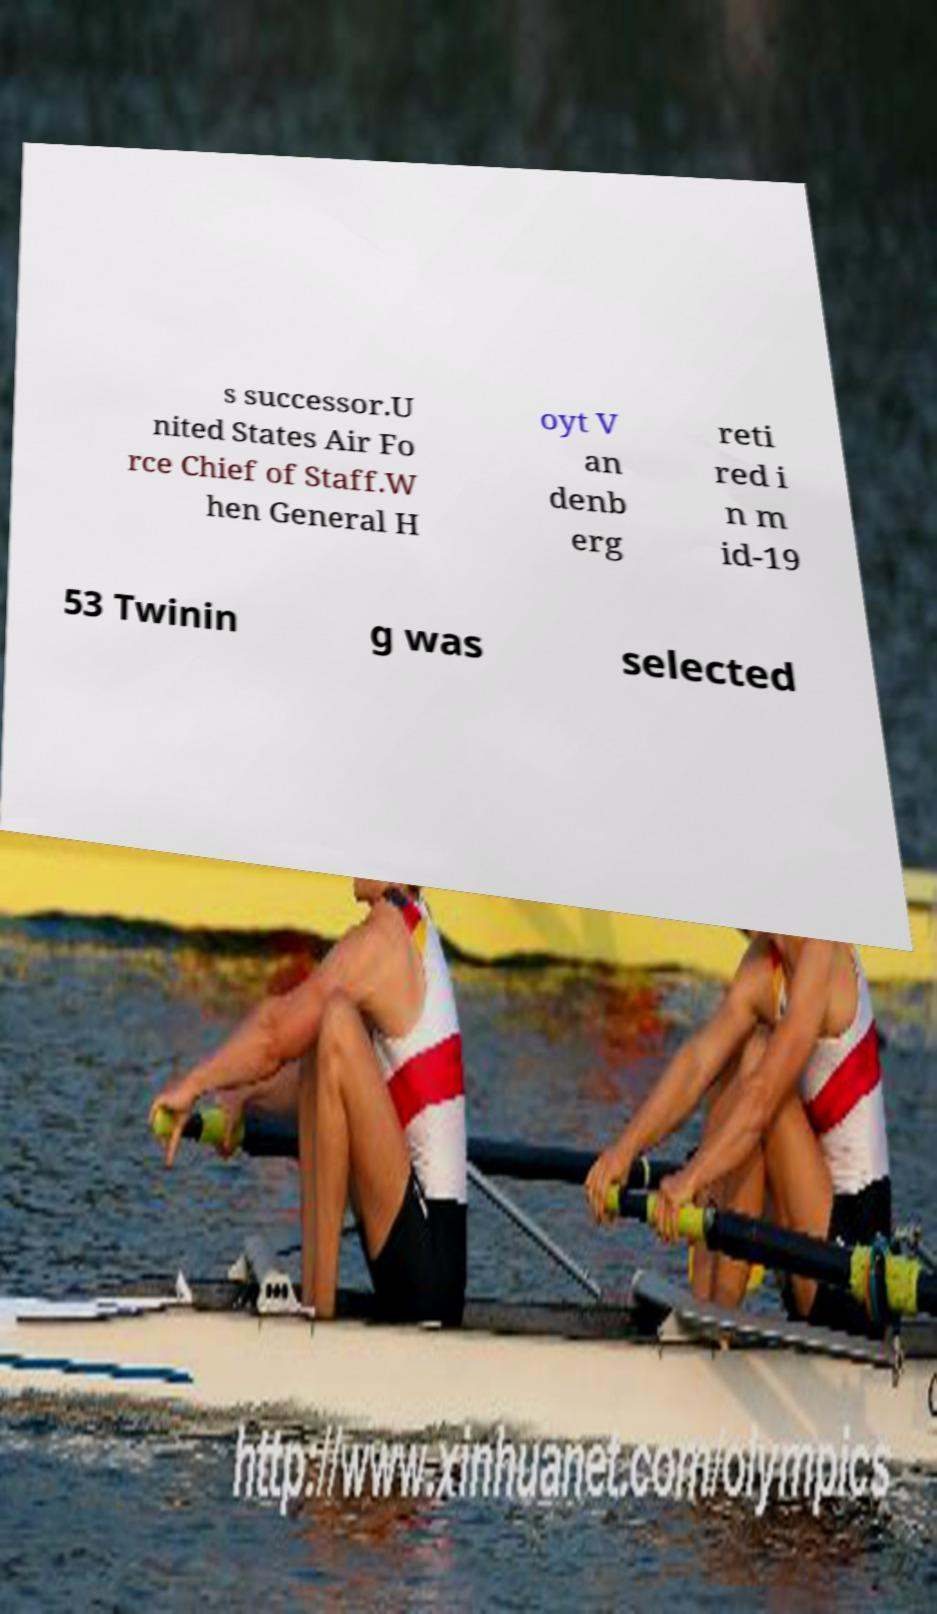Could you extract and type out the text from this image? s successor.U nited States Air Fo rce Chief of Staff.W hen General H oyt V an denb erg reti red i n m id-19 53 Twinin g was selected 